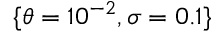<formula> <loc_0><loc_0><loc_500><loc_500>\{ \theta = 1 0 ^ { - 2 } , \sigma = 0 . 1 \}</formula> 